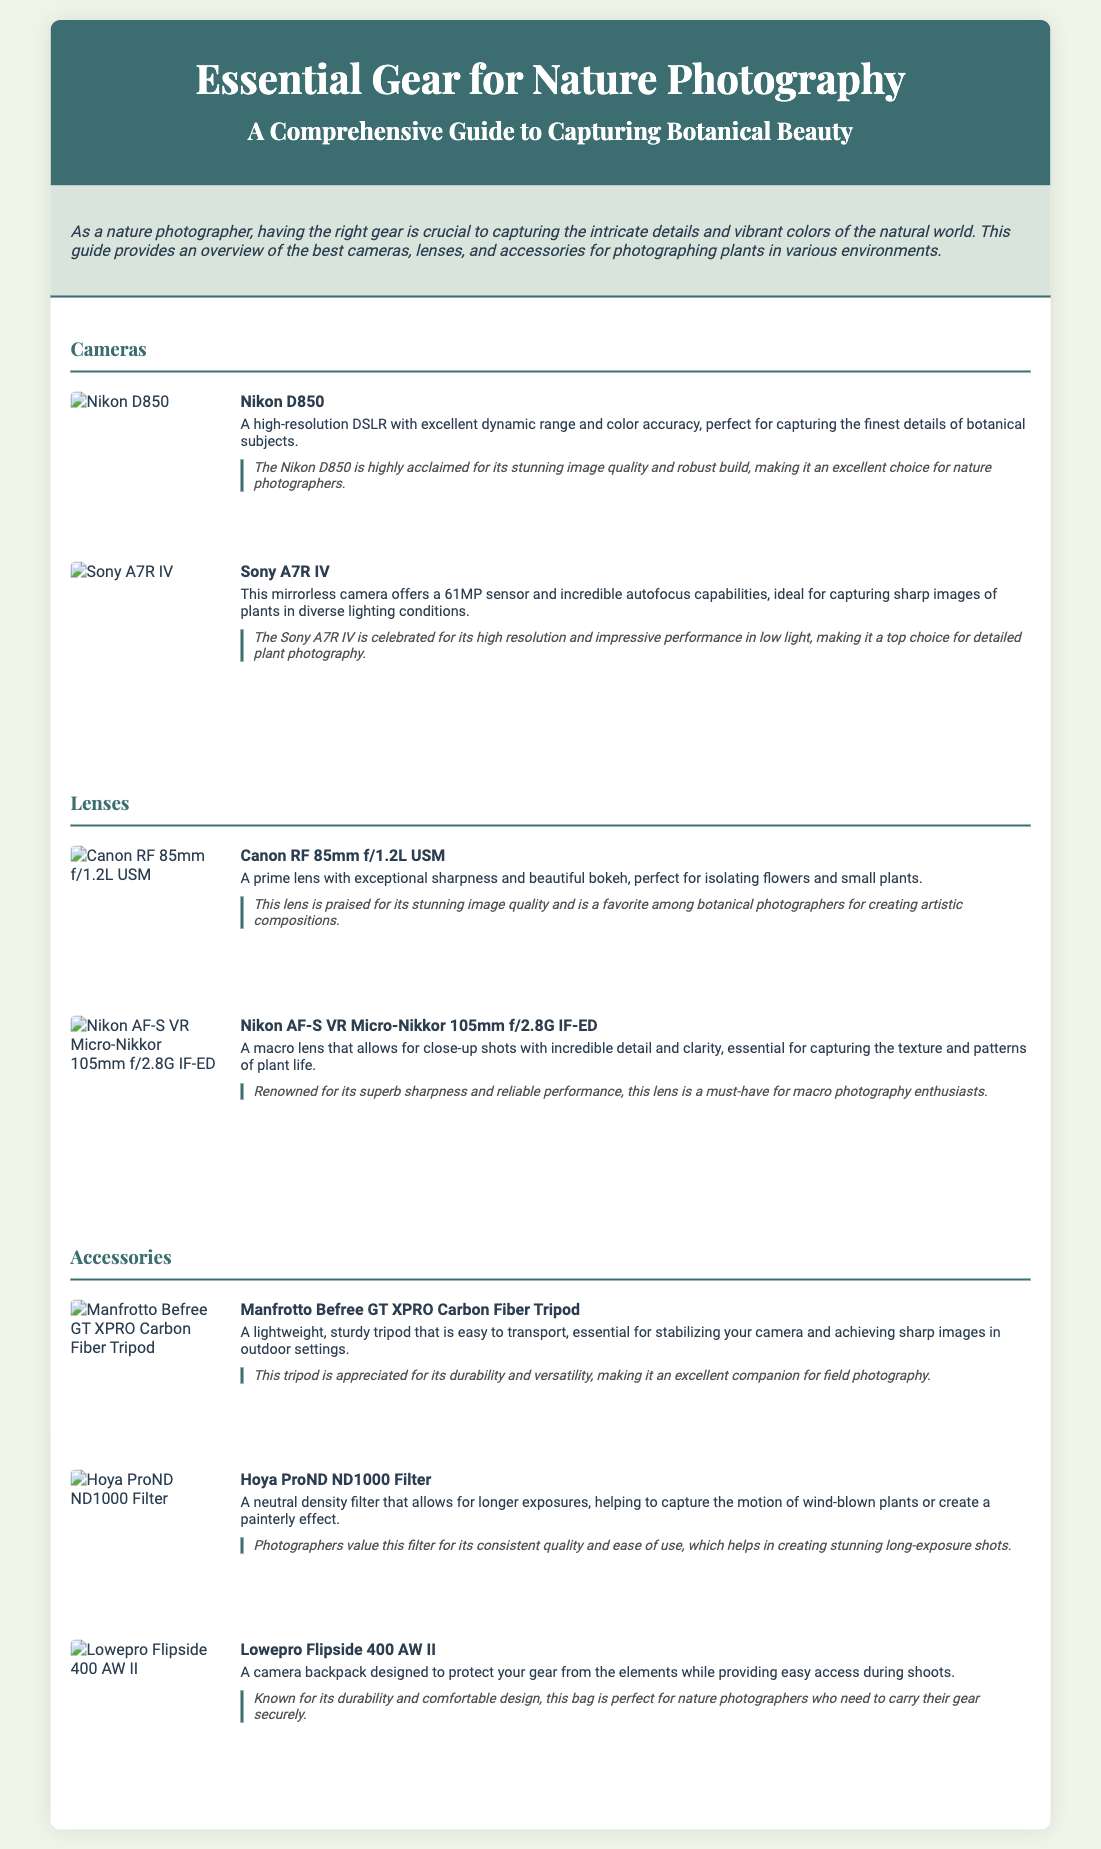what is the title of the document? The title is stated as the main heading at the top of the document, "Essential Gear for Nature Photography".
Answer: Essential Gear for Nature Photography how many cameras are listed in the document? The section titled "Cameras" contains two entries for specific cameras.
Answer: 2 what is the first lens mentioned in the document? The first lens described in the "Lenses" section is identified immediately after the section header.
Answer: Canon RF 85mm f/1.2L USM what is the purpose of the Hoya ProND ND1000 Filter? The document describes the purpose of this filter under its description, which explains its function for capturing long exposures.
Answer: Longer exposures which camera is noted for its high resolution and low light performance? The review section under the "Cameras" mentions the Sony A7R IV specifically for these qualities.
Answer: Sony A7R IV how is the Manfrotto Befree GT XPRO Carbon Fiber Tripod described? The camera accessory's description in the document highlights its lightweight and sturdy features, essential for stabilizing a camera.
Answer: Lightweight, sturdy what type of photography is the Nikon AF-S VR Micro-Nikkor 105mm f/2.8G IF-ED lens essential for? The description of the lens in the document specifies its role in capturing detailed plant life up close.
Answer: Macro photography how is the Lowepro Flipside 400 AW II characterized? The document describes this camera backpack as designed to protect gear and provide easy access during shoots.
Answer: Protect gear what aspect of the Nikon D850 is praised in the document? The review comments on the Nikon D850 highlight its stunning image quality and robust build.
Answer: Stunning image quality 